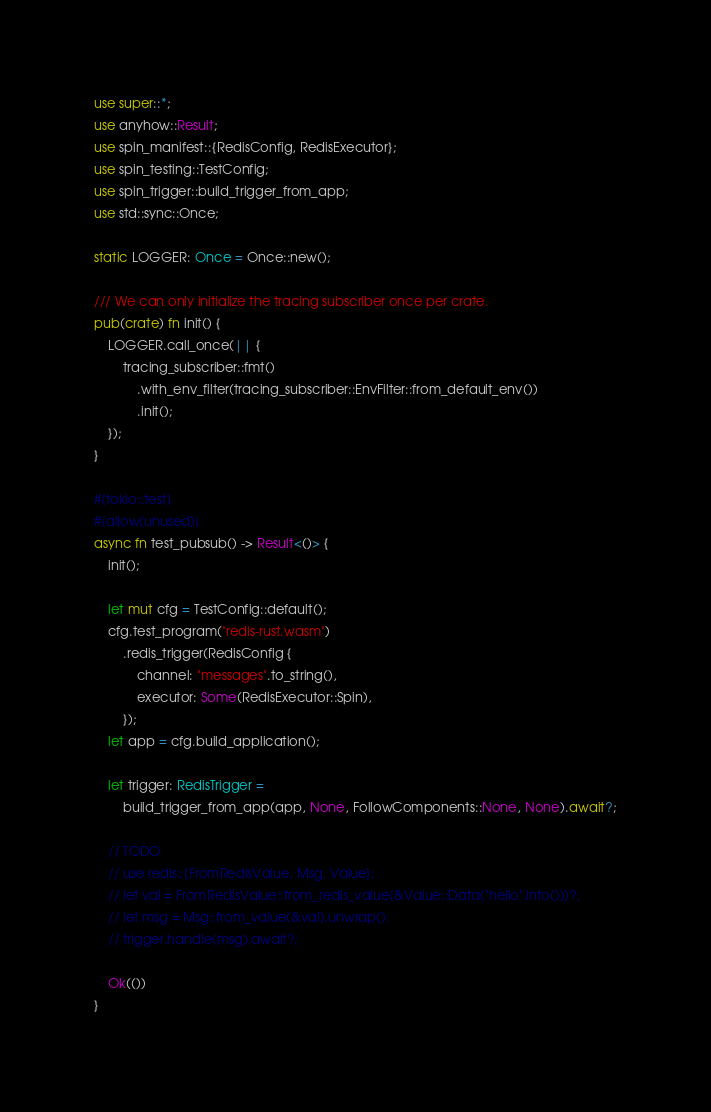<code> <loc_0><loc_0><loc_500><loc_500><_Rust_>use super::*;
use anyhow::Result;
use spin_manifest::{RedisConfig, RedisExecutor};
use spin_testing::TestConfig;
use spin_trigger::build_trigger_from_app;
use std::sync::Once;

static LOGGER: Once = Once::new();

/// We can only initialize the tracing subscriber once per crate.
pub(crate) fn init() {
    LOGGER.call_once(|| {
        tracing_subscriber::fmt()
            .with_env_filter(tracing_subscriber::EnvFilter::from_default_env())
            .init();
    });
}

#[tokio::test]
#[allow(unused)]
async fn test_pubsub() -> Result<()> {
    init();

    let mut cfg = TestConfig::default();
    cfg.test_program("redis-rust.wasm")
        .redis_trigger(RedisConfig {
            channel: "messages".to_string(),
            executor: Some(RedisExecutor::Spin),
        });
    let app = cfg.build_application();

    let trigger: RedisTrigger =
        build_trigger_from_app(app, None, FollowComponents::None, None).await?;

    // TODO
    // use redis::{FromRedisValue, Msg, Value};
    // let val = FromRedisValue::from_redis_value(&Value::Data("hello".into()))?;
    // let msg = Msg::from_value(&val).unwrap();
    // trigger.handle(msg).await?;

    Ok(())
}
</code> 